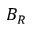<formula> <loc_0><loc_0><loc_500><loc_500>B _ { R }</formula> 